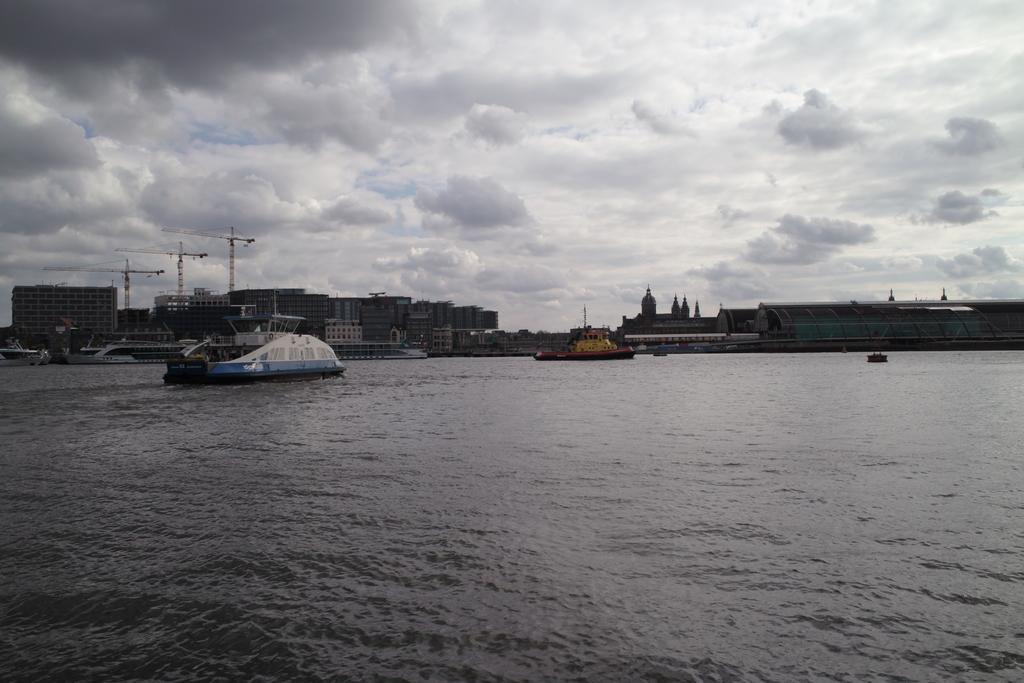How would you summarize this image in a sentence or two? This is an outside view. At the bottom there is a sea and I can see few boats on the water. In the background there are few buildings. On the left side there are three cranes. At the top of the image I can see the sky and clouds. 